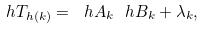Convert formula to latex. <formula><loc_0><loc_0><loc_500><loc_500>\ h T _ { h ( k ) } = \ h A _ { k } \ h B _ { k } + \lambda _ { k } ,</formula> 